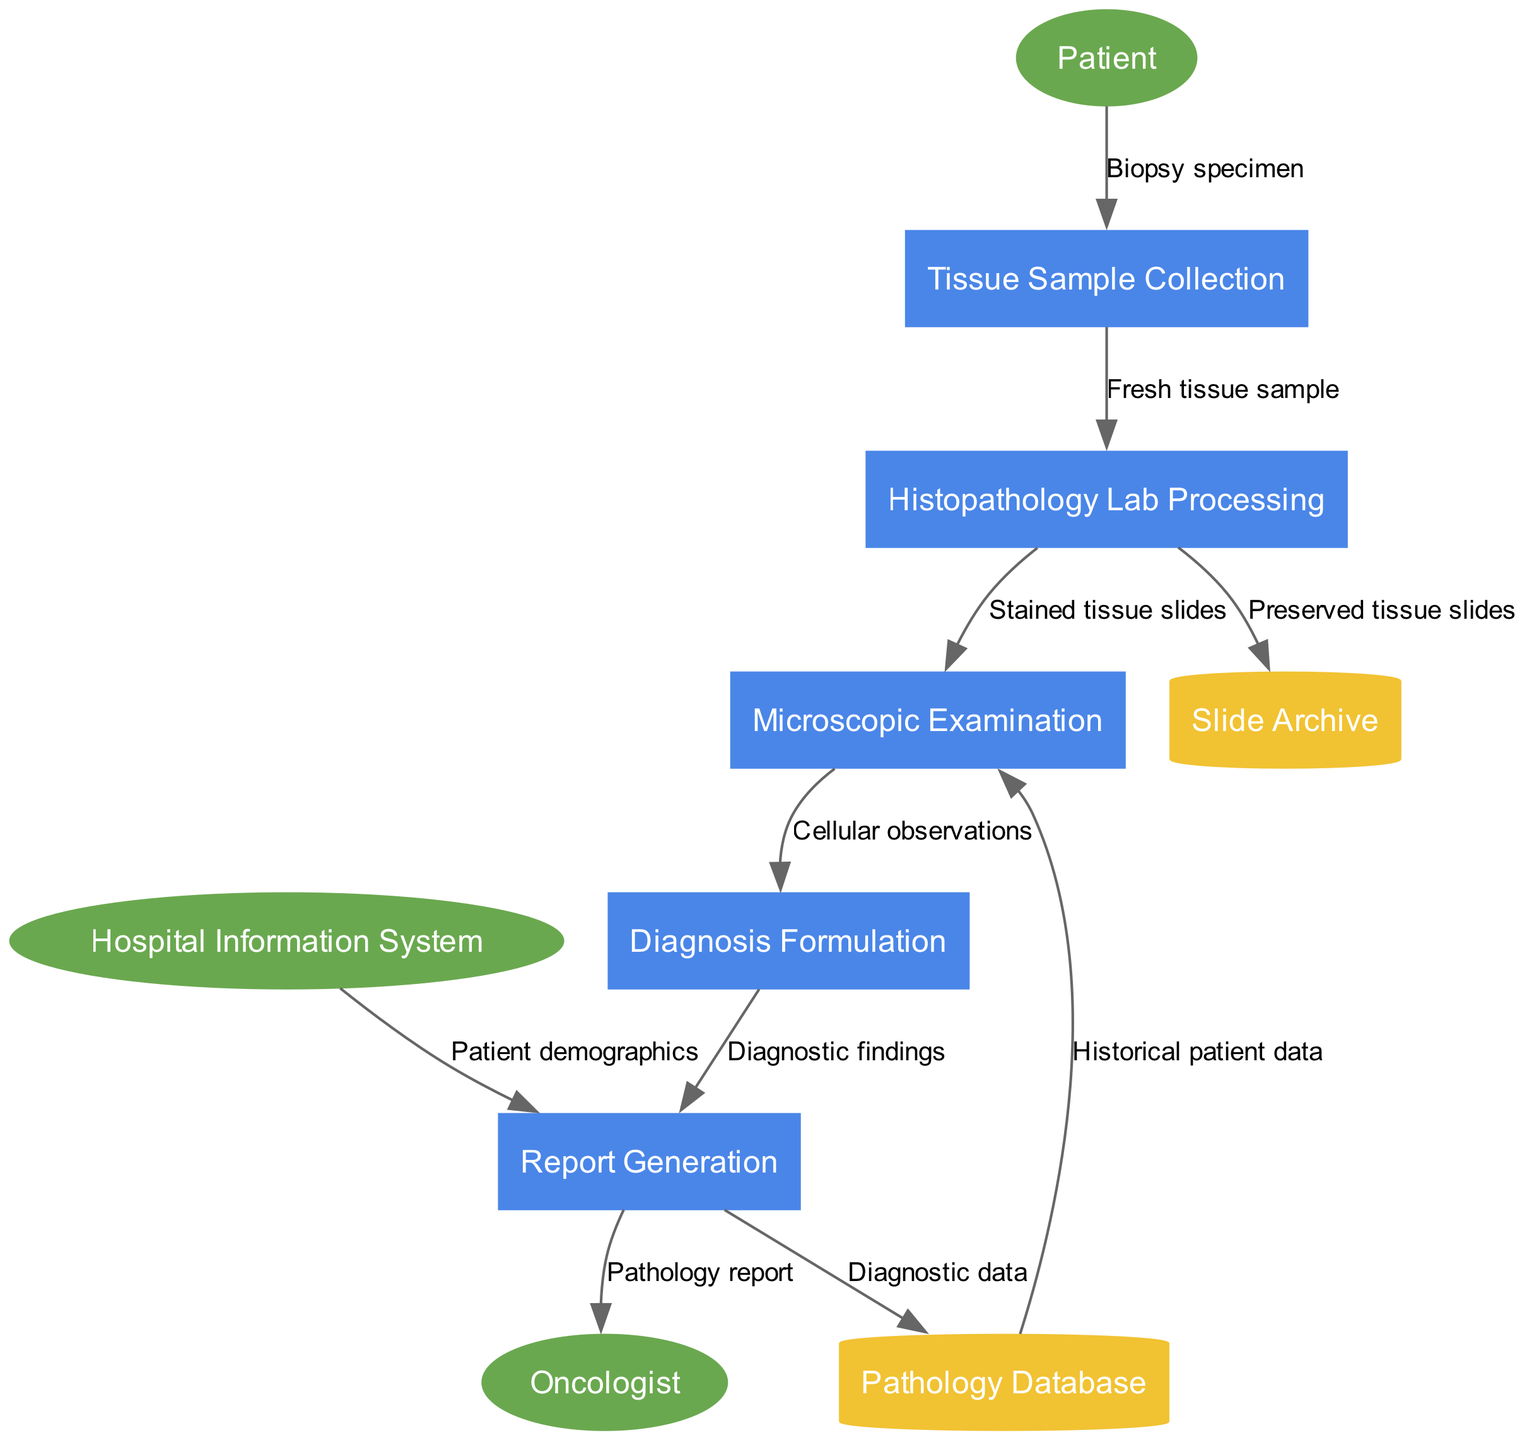What is the first process in the diagram? The first process listed in the diagram is "Tissue Sample Collection." This is the starting point of the data flow in the biopsy analysis.
Answer: Tissue Sample Collection How many external entities are present in the diagram? There are three external entities listed in the diagram: "Oncologist," "Patient," and "Hospital Information System." Each represents a participant that interacts with the processes.
Answer: 3 What data flow connects "Microscopic Examination" to "Diagnosis Formulation"? The data flow that connects "Microscopic Examination" to "Diagnosis Formulation" is labeled "Cellular observations." This indicates what information is passed from one process to the other.
Answer: Cellular observations Which process generates the "Pathology report"? The process that generates the "Pathology report" is "Report Generation." This is the final step of the analysis and is directed towards the oncologist.
Answer: Report Generation What type of external entity is "Patient"? "Patient" is classified as an external entity. In a Data Flow Diagram, external entities refer to sources or destinations of data within the system.
Answer: External Entity What does the "Pathology Database" store, according to the data flows? The "Pathology Database" stores the "Diagnostic data." This is an important data store as it collects and retains information derived from the diagnostic process.
Answer: Diagnostic data How many processes are involved in the diagram? The number of processes listed in the diagram is five: "Tissue Sample Collection," "Histopathology Lab Processing," "Microscopic Examination," "Diagnosis Formulation," and "Report Generation." Each process is a step in the workflow.
Answer: 5 What information flows from "Hospital Information System" to "Report Generation"? The information flowing from "Hospital Information System" to "Report Generation" is described as "Patient demographics." This data is important for compiling the report.
Answer: Patient demographics What type of data store is "Slide Archive"? "Slide Archive" is classified as a data store. In Data Flow Diagrams, data stores such as this one hold and organize stored data related to the processes being performed.
Answer: Data Store 